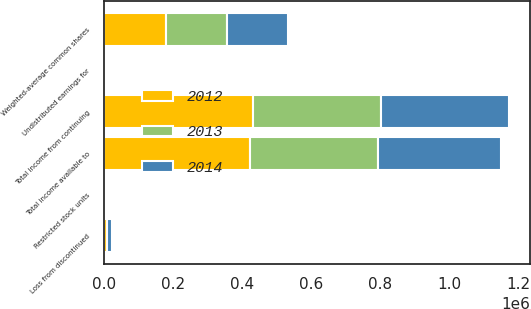Convert chart to OTSL. <chart><loc_0><loc_0><loc_500><loc_500><stacked_bar_chart><ecel><fcel>Total income from continuing<fcel>Loss from discontinued<fcel>Total income available to<fcel>Undistributed earnings for<fcel>Weighted-average common shares<fcel>Restricted stock units<nl><fcel>2012<fcel>429778<fcel>6733<fcel>423045<fcel>57<fcel>178888<fcel>454<nl><fcel>2013<fcel>370784<fcel>1580<fcel>369204<fcel>84<fcel>177814<fcel>510<nl><fcel>2014<fcel>373516<fcel>15532<fcel>357984<fcel>58<fcel>176445<fcel>618<nl></chart> 